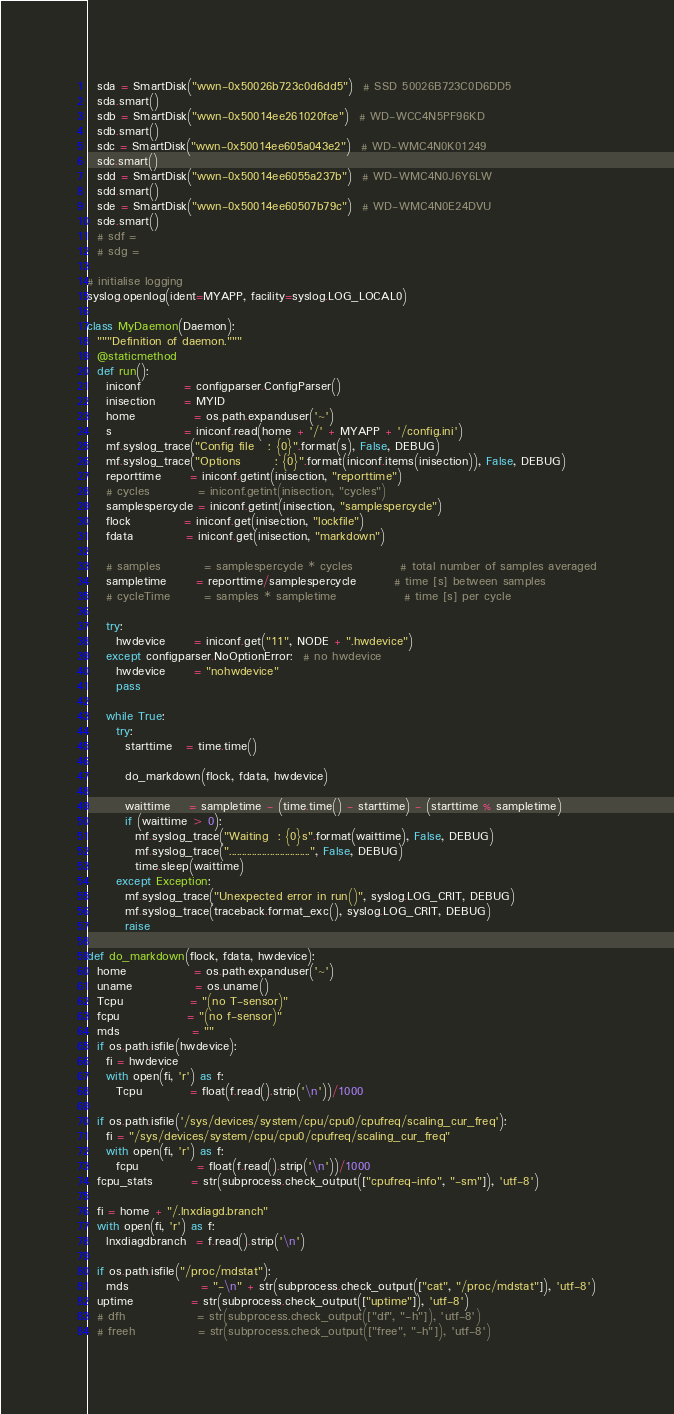<code> <loc_0><loc_0><loc_500><loc_500><_Python_>  sda = SmartDisk("wwn-0x50026b723c0d6dd5")  # SSD 50026B723C0D6DD5
  sda.smart()
  sdb = SmartDisk("wwn-0x50014ee261020fce")  # WD-WCC4N5PF96KD
  sdb.smart()
  sdc = SmartDisk("wwn-0x50014ee605a043e2")  # WD-WMC4N0K01249
  sdc.smart()
  sdd = SmartDisk("wwn-0x50014ee6055a237b")  # WD-WMC4N0J6Y6LW
  sdd.smart()
  sde = SmartDisk("wwn-0x50014ee60507b79c")  # WD-WMC4N0E24DVU
  sde.smart()
  # sdf =
  # sdg =

# initialise logging
syslog.openlog(ident=MYAPP, facility=syslog.LOG_LOCAL0)

class MyDaemon(Daemon):
  """Definition of daemon."""
  @staticmethod
  def run():
    iniconf         = configparser.ConfigParser()
    inisection      = MYID
    home            = os.path.expanduser('~')
    s               = iniconf.read(home + '/' + MYAPP + '/config.ini')
    mf.syslog_trace("Config file   : {0}".format(s), False, DEBUG)
    mf.syslog_trace("Options       : {0}".format(iniconf.items(inisection)), False, DEBUG)
    reporttime      = iniconf.getint(inisection, "reporttime")
    # cycles          = iniconf.getint(inisection, "cycles")
    samplespercycle = iniconf.getint(inisection, "samplespercycle")
    flock           = iniconf.get(inisection, "lockfile")
    fdata           = iniconf.get(inisection, "markdown")

    # samples         = samplespercycle * cycles          # total number of samples averaged
    sampletime      = reporttime/samplespercycle        # time [s] between samples
    # cycleTime       = samples * sampletime              # time [s] per cycle

    try:
      hwdevice      = iniconf.get("11", NODE + ".hwdevice")
    except configparser.NoOptionError:  # no hwdevice
      hwdevice      = "nohwdevice"
      pass

    while True:
      try:
        starttime   = time.time()

        do_markdown(flock, fdata, hwdevice)

        waittime    = sampletime - (time.time() - starttime) - (starttime % sampletime)
        if (waittime > 0):
          mf.syslog_trace("Waiting  : {0}s".format(waittime), False, DEBUG)
          mf.syslog_trace("................................", False, DEBUG)
          time.sleep(waittime)
      except Exception:
        mf.syslog_trace("Unexpected error in run()", syslog.LOG_CRIT, DEBUG)
        mf.syslog_trace(traceback.format_exc(), syslog.LOG_CRIT, DEBUG)
        raise

def do_markdown(flock, fdata, hwdevice):
  home              = os.path.expanduser('~')
  uname             = os.uname()
  Tcpu              = "(no T-sensor)"
  fcpu              = "(no f-sensor)"
  mds               = ""
  if os.path.isfile(hwdevice):
    fi = hwdevice
    with open(fi, 'r') as f:
      Tcpu          = float(f.read().strip('\n'))/1000

  if os.path.isfile('/sys/devices/system/cpu/cpu0/cpufreq/scaling_cur_freq'):
    fi = "/sys/devices/system/cpu/cpu0/cpufreq/scaling_cur_freq"
    with open(fi, 'r') as f:
      fcpu            = float(f.read().strip('\n'))/1000
  fcpu_stats        = str(subprocess.check_output(["cpufreq-info", "-sm"]), 'utf-8')

  fi = home + "/.lnxdiagd.branch"
  with open(fi, 'r') as f:
    lnxdiagdbranch  = f.read().strip('\n')

  if os.path.isfile("/proc/mdstat"):
    mds               = "-\n" + str(subprocess.check_output(["cat", "/proc/mdstat"]), 'utf-8')
  uptime            = str(subprocess.check_output(["uptime"]), 'utf-8')
  # dfh               = str(subprocess.check_output(["df", "-h"]), 'utf-8')
  # freeh             = str(subprocess.check_output(["free", "-h"]), 'utf-8')</code> 